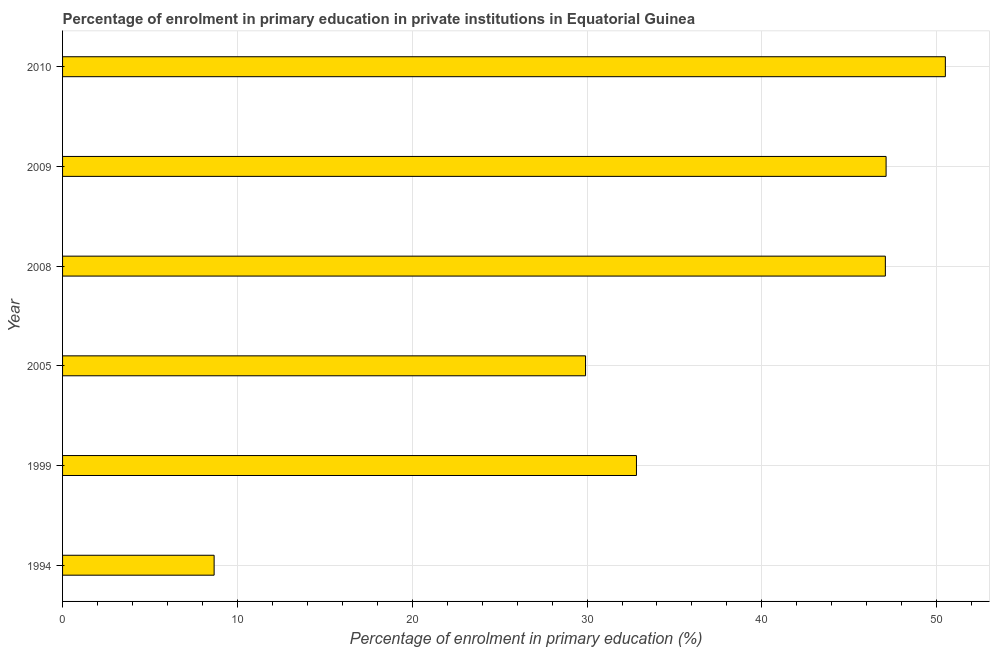What is the title of the graph?
Provide a succinct answer. Percentage of enrolment in primary education in private institutions in Equatorial Guinea. What is the label or title of the X-axis?
Give a very brief answer. Percentage of enrolment in primary education (%). What is the label or title of the Y-axis?
Your answer should be compact. Year. What is the enrolment percentage in primary education in 2010?
Keep it short and to the point. 50.5. Across all years, what is the maximum enrolment percentage in primary education?
Give a very brief answer. 50.5. Across all years, what is the minimum enrolment percentage in primary education?
Provide a short and direct response. 8.67. In which year was the enrolment percentage in primary education minimum?
Provide a short and direct response. 1994. What is the sum of the enrolment percentage in primary education?
Provide a short and direct response. 216.07. What is the difference between the enrolment percentage in primary education in 1994 and 2008?
Make the answer very short. -38.39. What is the average enrolment percentage in primary education per year?
Provide a short and direct response. 36.01. What is the median enrolment percentage in primary education?
Your answer should be compact. 39.94. What is the ratio of the enrolment percentage in primary education in 2009 to that in 2010?
Keep it short and to the point. 0.93. What is the difference between the highest and the second highest enrolment percentage in primary education?
Ensure brevity in your answer.  3.39. Is the sum of the enrolment percentage in primary education in 2005 and 2010 greater than the maximum enrolment percentage in primary education across all years?
Keep it short and to the point. Yes. What is the difference between the highest and the lowest enrolment percentage in primary education?
Keep it short and to the point. 41.83. In how many years, is the enrolment percentage in primary education greater than the average enrolment percentage in primary education taken over all years?
Your answer should be very brief. 3. Are all the bars in the graph horizontal?
Make the answer very short. Yes. What is the difference between two consecutive major ticks on the X-axis?
Keep it short and to the point. 10. What is the Percentage of enrolment in primary education (%) in 1994?
Offer a very short reply. 8.67. What is the Percentage of enrolment in primary education (%) of 1999?
Provide a short and direct response. 32.83. What is the Percentage of enrolment in primary education (%) in 2005?
Offer a terse response. 29.91. What is the Percentage of enrolment in primary education (%) in 2008?
Your response must be concise. 47.06. What is the Percentage of enrolment in primary education (%) of 2009?
Provide a succinct answer. 47.11. What is the Percentage of enrolment in primary education (%) of 2010?
Your answer should be very brief. 50.5. What is the difference between the Percentage of enrolment in primary education (%) in 1994 and 1999?
Make the answer very short. -24.16. What is the difference between the Percentage of enrolment in primary education (%) in 1994 and 2005?
Offer a terse response. -21.25. What is the difference between the Percentage of enrolment in primary education (%) in 1994 and 2008?
Give a very brief answer. -38.39. What is the difference between the Percentage of enrolment in primary education (%) in 1994 and 2009?
Provide a succinct answer. -38.44. What is the difference between the Percentage of enrolment in primary education (%) in 1994 and 2010?
Offer a very short reply. -41.83. What is the difference between the Percentage of enrolment in primary education (%) in 1999 and 2005?
Ensure brevity in your answer.  2.91. What is the difference between the Percentage of enrolment in primary education (%) in 1999 and 2008?
Provide a short and direct response. -14.24. What is the difference between the Percentage of enrolment in primary education (%) in 1999 and 2009?
Your answer should be very brief. -14.28. What is the difference between the Percentage of enrolment in primary education (%) in 1999 and 2010?
Provide a succinct answer. -17.67. What is the difference between the Percentage of enrolment in primary education (%) in 2005 and 2008?
Offer a very short reply. -17.15. What is the difference between the Percentage of enrolment in primary education (%) in 2005 and 2009?
Offer a terse response. -17.19. What is the difference between the Percentage of enrolment in primary education (%) in 2005 and 2010?
Offer a very short reply. -20.58. What is the difference between the Percentage of enrolment in primary education (%) in 2008 and 2009?
Provide a succinct answer. -0.04. What is the difference between the Percentage of enrolment in primary education (%) in 2008 and 2010?
Your answer should be very brief. -3.43. What is the difference between the Percentage of enrolment in primary education (%) in 2009 and 2010?
Your response must be concise. -3.39. What is the ratio of the Percentage of enrolment in primary education (%) in 1994 to that in 1999?
Offer a terse response. 0.26. What is the ratio of the Percentage of enrolment in primary education (%) in 1994 to that in 2005?
Your answer should be compact. 0.29. What is the ratio of the Percentage of enrolment in primary education (%) in 1994 to that in 2008?
Your answer should be compact. 0.18. What is the ratio of the Percentage of enrolment in primary education (%) in 1994 to that in 2009?
Keep it short and to the point. 0.18. What is the ratio of the Percentage of enrolment in primary education (%) in 1994 to that in 2010?
Ensure brevity in your answer.  0.17. What is the ratio of the Percentage of enrolment in primary education (%) in 1999 to that in 2005?
Keep it short and to the point. 1.1. What is the ratio of the Percentage of enrolment in primary education (%) in 1999 to that in 2008?
Offer a very short reply. 0.7. What is the ratio of the Percentage of enrolment in primary education (%) in 1999 to that in 2009?
Your answer should be very brief. 0.7. What is the ratio of the Percentage of enrolment in primary education (%) in 1999 to that in 2010?
Your answer should be compact. 0.65. What is the ratio of the Percentage of enrolment in primary education (%) in 2005 to that in 2008?
Provide a succinct answer. 0.64. What is the ratio of the Percentage of enrolment in primary education (%) in 2005 to that in 2009?
Your response must be concise. 0.64. What is the ratio of the Percentage of enrolment in primary education (%) in 2005 to that in 2010?
Provide a short and direct response. 0.59. What is the ratio of the Percentage of enrolment in primary education (%) in 2008 to that in 2010?
Offer a terse response. 0.93. What is the ratio of the Percentage of enrolment in primary education (%) in 2009 to that in 2010?
Offer a terse response. 0.93. 